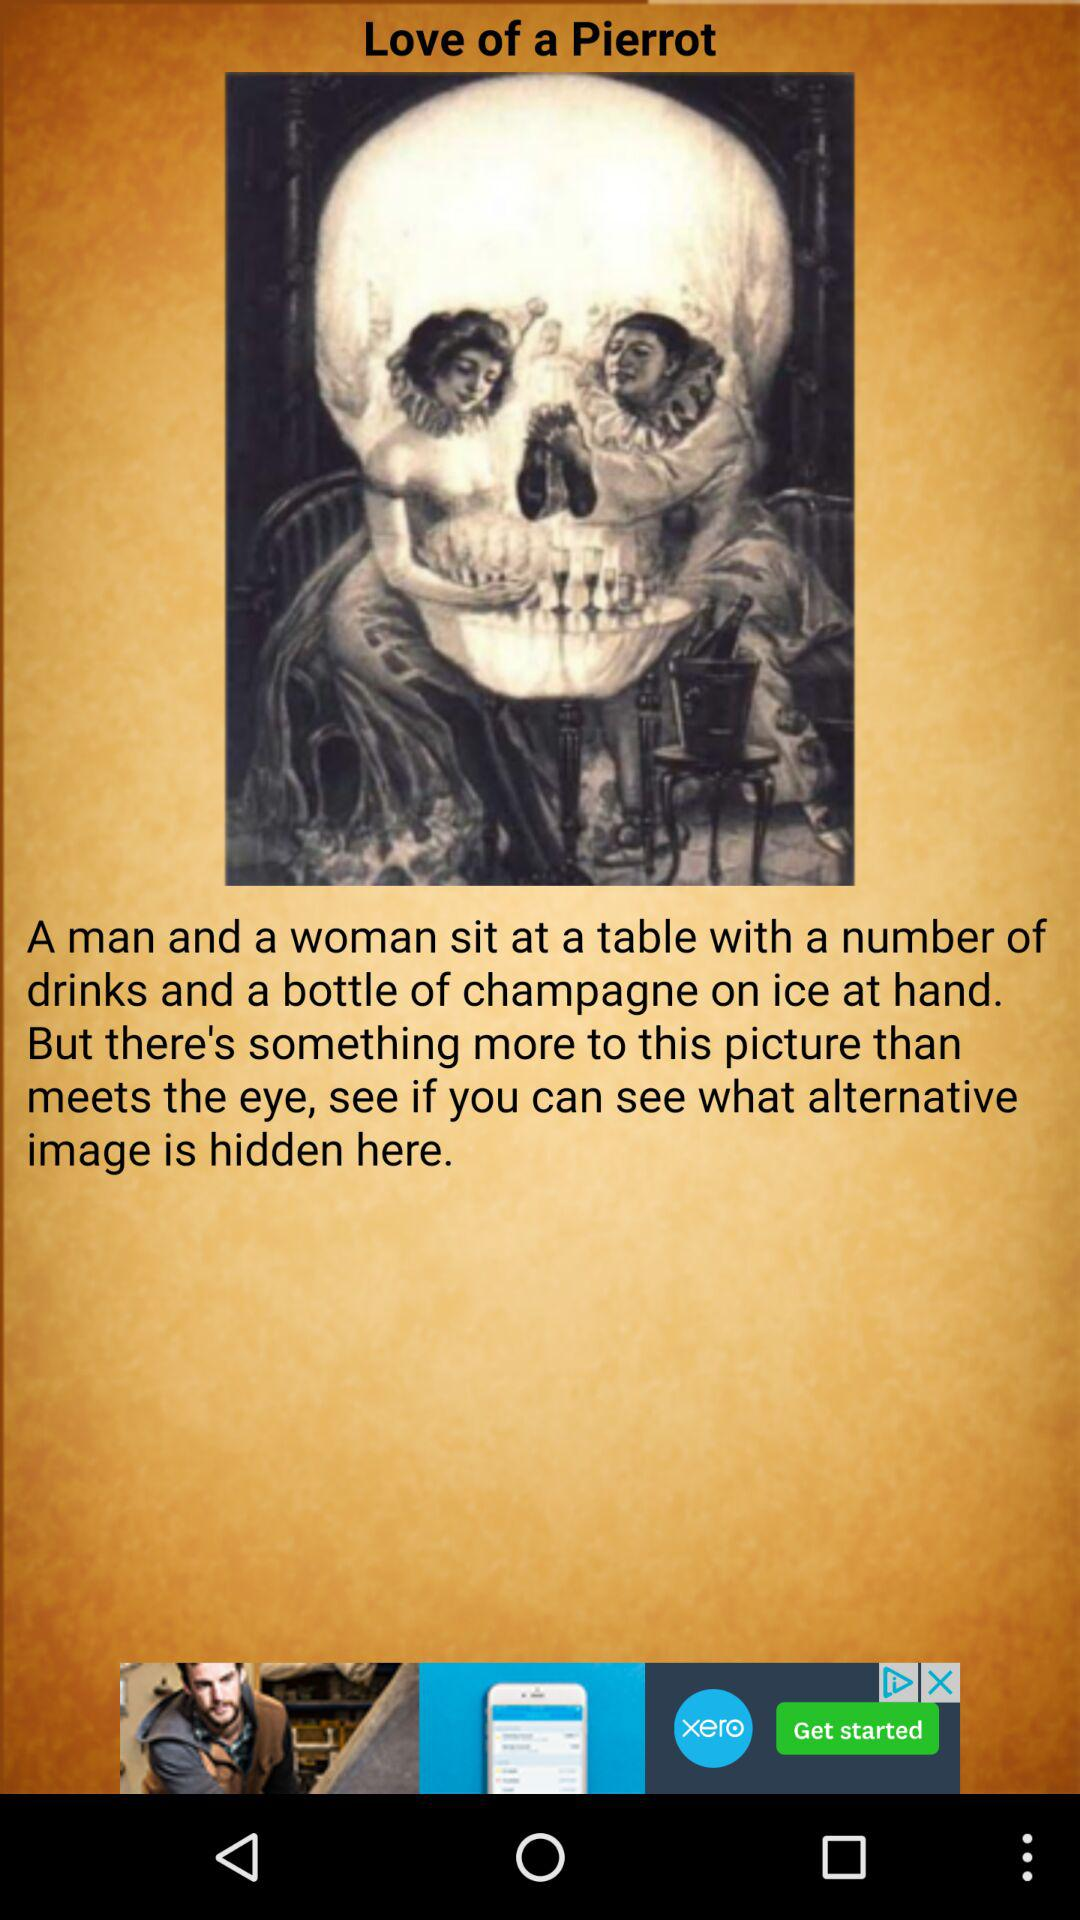What is the name of the printed art? The name of the printed art is "Love of a Pierrot". 